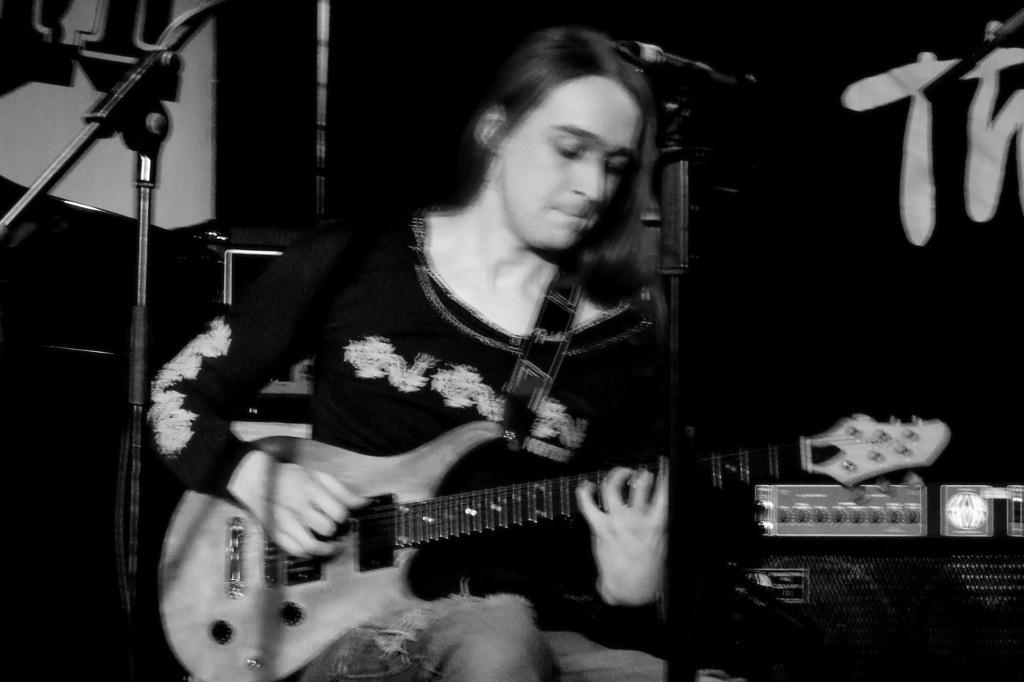What is the color scheme of the image? The image is black and white. Who is the main subject in the image? There is a lady in the image. What is the lady holding in the image? The lady is holding a guitar. What objects are in front of the lady? There are microphones in front of the lady. What can be seen in the background of the image? There is black text written in the background. What type of bushes can be seen growing around the lady in the image? There are no bushes visible in the image; it is a black and white image featuring a lady holding a guitar and microphones in front of her. What color is the lady's lipstick in the image? The image is black and white, so it is not possible to determine the color of the lady's lipstick. 